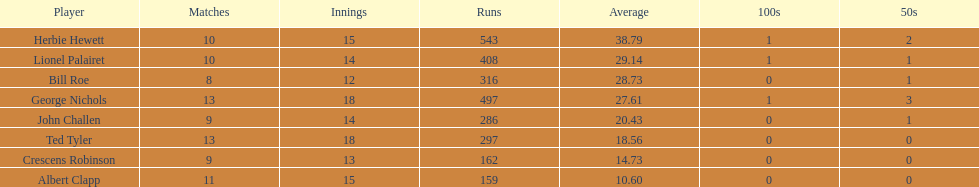Can you mention a player who has taken part in a maximum of 13 innings? Bill Roe. 